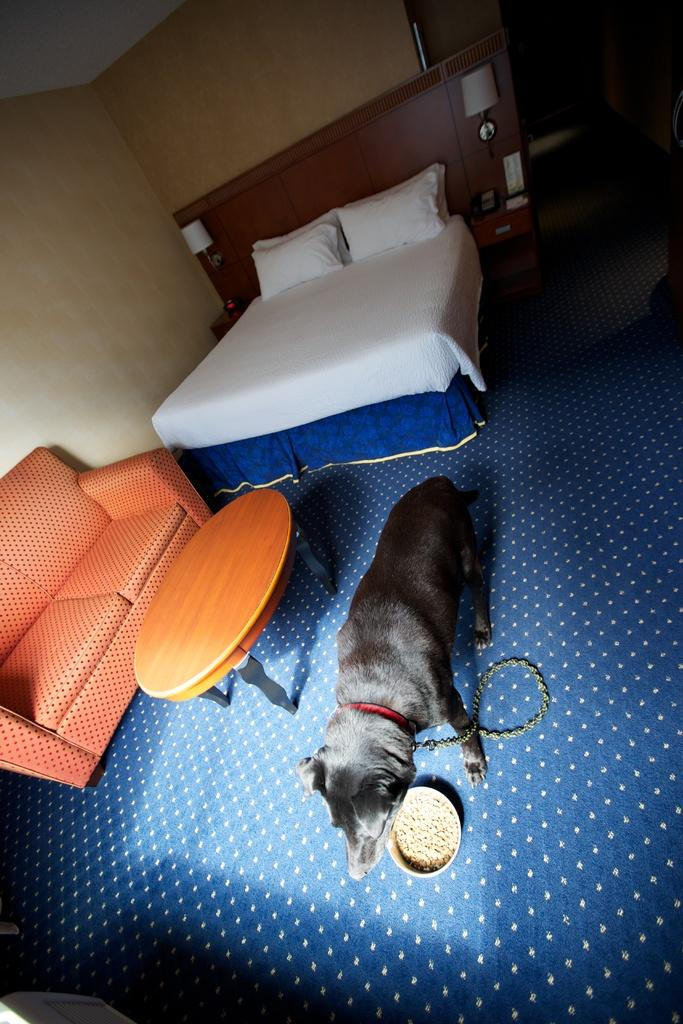What animal can be seen in the image? There is a dog in the image. What is the dog doing in the image? The dog is eating food from a plate. What furniture is present in the image? There is a table, a couch, and a bed in the image. What items are on the bed? There is a blanket and two pillows on the bed. What type of lighting is present in the image? There is a lamp in the image. What architectural feature is visible in the image? There is a wall in the image. What type of liquid is being poured from the rifle in the image? There is no rifle or liquid present in the image. 